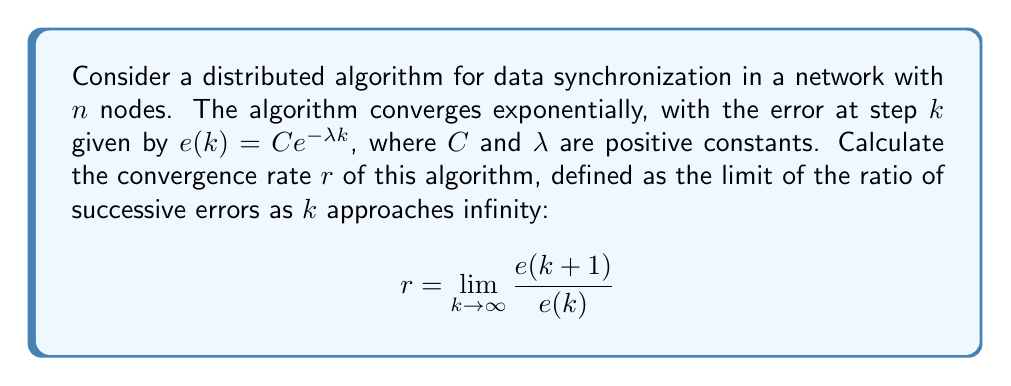Provide a solution to this math problem. Let's approach this step-by-step:

1) We start with the given error function:
   $$e(k) = Ce^{-\lambda k}$$

2) We need to find $e(k+1)$:
   $$e(k+1) = Ce^{-\lambda (k+1)}$$

3) Now, let's form the ratio $\frac{e(k+1)}{e(k)}$:
   $$\frac{e(k+1)}{e(k)} = \frac{Ce^{-\lambda (k+1)}}{Ce^{-\lambda k}}$$

4) The constant $C$ cancels out:
   $$\frac{e(k+1)}{e(k)} = \frac{e^{-\lambda (k+1)}}{e^{-\lambda k}}$$

5) Using the properties of exponents, we can simplify:
   $$\frac{e(k+1)}{e(k)} = \frac{e^{-\lambda k} \cdot e^{-\lambda}}{e^{-\lambda k}} = e^{-\lambda}$$

6) Notice that this ratio is independent of $k$. Therefore, the limit as $k$ approaches infinity will be the same value:

   $$r = \lim_{k \to \infty} \frac{e(k+1)}{e(k)} = e^{-\lambda}$$

This result shows that the convergence rate is constant and depends only on $\lambda$. Since $\lambda > 0$, we have $0 < e^{-\lambda} < 1$, which confirms the exponential convergence.
Answer: $e^{-\lambda}$ 